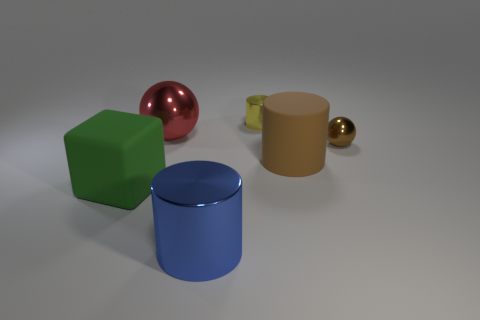Add 2 small balls. How many objects exist? 8 Subtract all cubes. How many objects are left? 5 Add 1 tiny yellow metallic objects. How many tiny yellow metallic objects are left? 2 Add 5 green shiny objects. How many green shiny objects exist? 5 Subtract 0 blue balls. How many objects are left? 6 Subtract all cylinders. Subtract all yellow metallic cylinders. How many objects are left? 2 